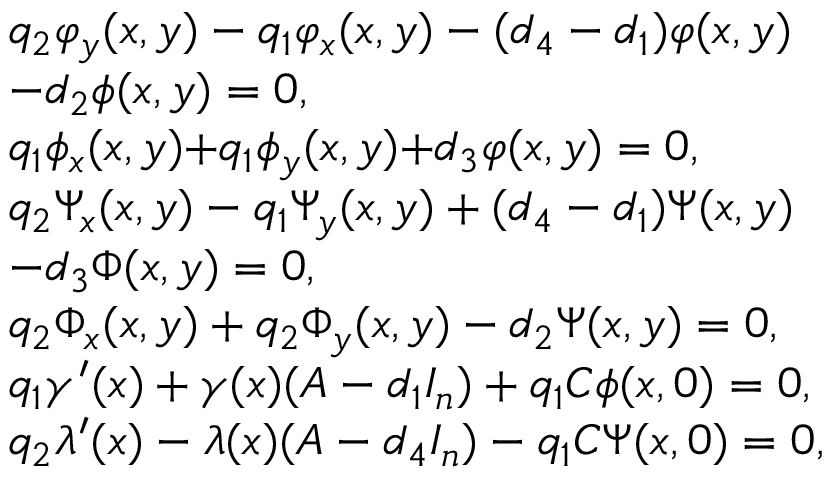Convert formula to latex. <formula><loc_0><loc_0><loc_500><loc_500>\begin{array} { r l } & { { q _ { 2 } } { { \varphi } _ { y } } ( x , y ) - { q _ { 1 } } { { \varphi } _ { x } } ( x , y ) - ( { d _ { 4 } } - { d _ { 1 } } ) \varphi ( x , y ) } \\ & { - { d _ { 2 } } \phi ( x , y ) = 0 , } \\ & { { { q _ { 1 } } { { \phi } _ { x } } ( x , y ) { + } { q _ { 1 } } { { \phi } _ { y } } ( x , y ) } { + } { d _ { 3 } } \varphi ( x , y ) = 0 , } \\ & { { q _ { 2 } } { { \Psi } _ { x } } ( x , y ) - { q _ { 1 } } { { \Psi } _ { y } } ( x , y ) + ( { d _ { 4 } } - { d _ { 1 } } ) \Psi ( x , y ) } \\ & { - { d _ { 3 } } \Phi ( x , y ) = 0 , } \\ & { { { q _ { 2 } } { \Phi _ { x } } ( x , y ) + { q _ { 2 } } { \Phi _ { y } } ( x , y ) - { d _ { 2 } } \Psi ( x , y ) } = 0 , } \\ & { { q _ { 1 } } { \gamma } ^ { \prime } ( x ) + { \gamma } ( x ) ( A - { d _ { 1 } } I _ { n } ) + { q _ { 1 } } { C } \phi ( x , 0 ) = 0 , } \\ & { { q _ { 2 } } \lambda ^ { \prime } ( x ) - { \lambda } ( x ) ( A - { d _ { 4 } } I _ { n } ) - { q _ { 1 } } { C } \Psi ( x , 0 ) = 0 , } \end{array}</formula> 